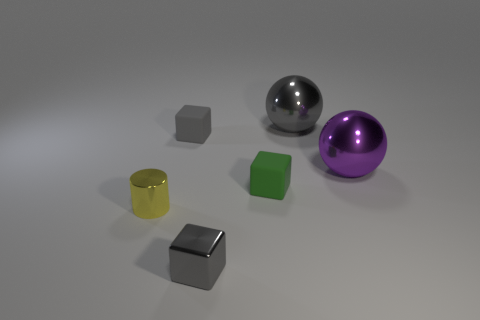Add 2 small yellow metal things. How many objects exist? 8 Subtract all cylinders. How many objects are left? 5 Subtract 0 blue cylinders. How many objects are left? 6 Subtract all large cyan metallic balls. Subtract all gray matte blocks. How many objects are left? 5 Add 1 big balls. How many big balls are left? 3 Add 4 large cyan shiny spheres. How many large cyan shiny spheres exist? 4 